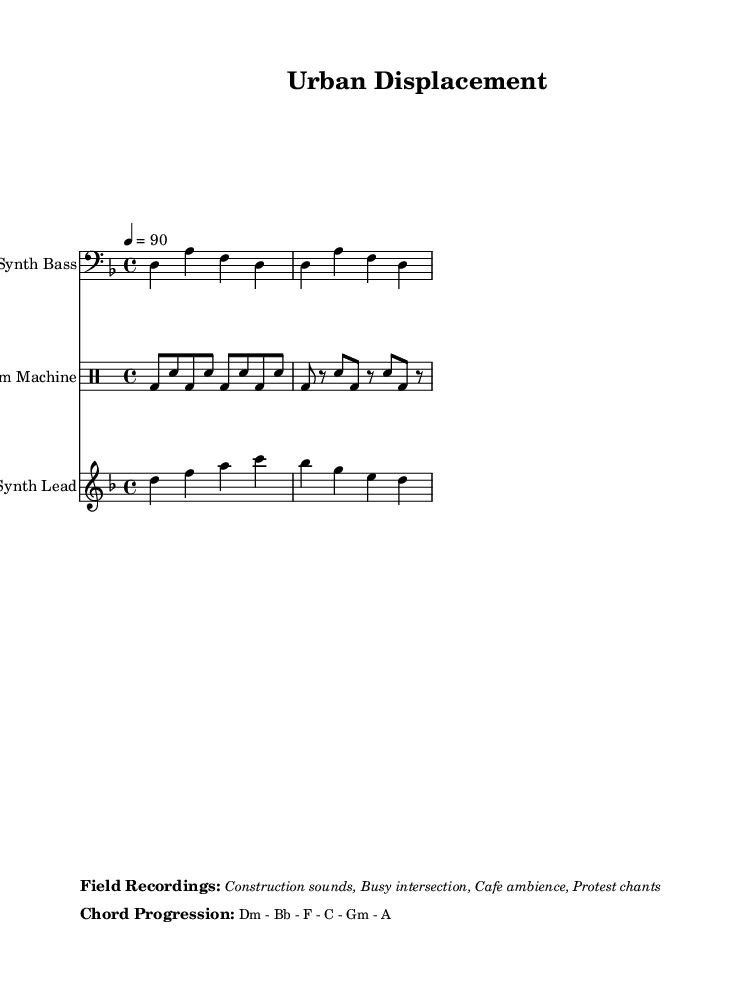What is the key signature of this music? The key signature is D minor, which has one flat (B flat). This can be identified in the global setting of the sheet music.
Answer: D minor What is the time signature of this piece? The time signature is 4/4, as indicated in the global section of the sheet music. This means there are four beats per measure.
Answer: 4/4 What is the tempo of the composition? The tempo is indicated as a quarter note equals 90 beats per minute. This is found in the global section where the tempo is specified.
Answer: 90 What is the chord progression used in this piece? The chord progression listed is Dm - Bb - F - C - Gm - A. This is mentioned in a markup section specifically noting the chord progression.
Answer: Dm - Bb - F - C - Gm - A What field recordings are included in the composition? The field recordings mentioned include construction sounds, a busy intersection, café ambience, and protest chants. This information is presented in the markup section labeled "Field Recordings."
Answer: Construction sounds, Busy intersection, Cafe ambience, Protest chants What instrument is used for the bass part? The bass part is performed on a synth bass, as indicated in the staff name at the beginning of that section.
Answer: Synth Bass What type of music is this composition categorized as? The composition is categorized as Glitch-hop, a subgenre of electronic music, which is evident from the context provided in the title and the thematic elements discussed.
Answer: Glitch-hop 